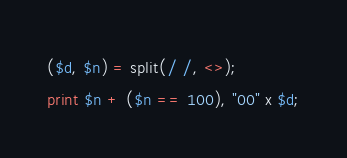Convert code to text. <code><loc_0><loc_0><loc_500><loc_500><_Perl_>($d, $n) = split(/ /, <>);
print $n + ($n == 100), "00" x $d;
</code> 